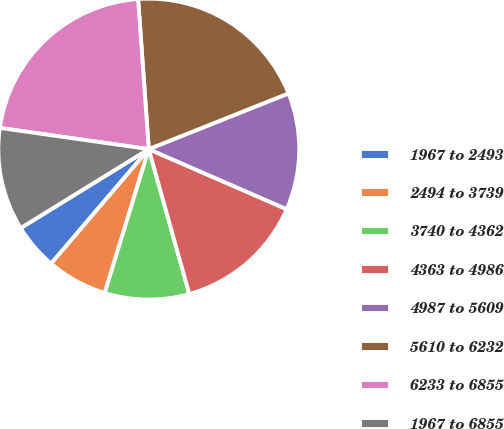<chart> <loc_0><loc_0><loc_500><loc_500><pie_chart><fcel>1967 to 2493<fcel>2494 to 3739<fcel>3740 to 4362<fcel>4363 to 4986<fcel>4987 to 5609<fcel>5610 to 6232<fcel>6233 to 6855<fcel>1967 to 6855<nl><fcel>4.97%<fcel>6.51%<fcel>9.07%<fcel>14.12%<fcel>12.58%<fcel>20.09%<fcel>21.62%<fcel>11.04%<nl></chart> 